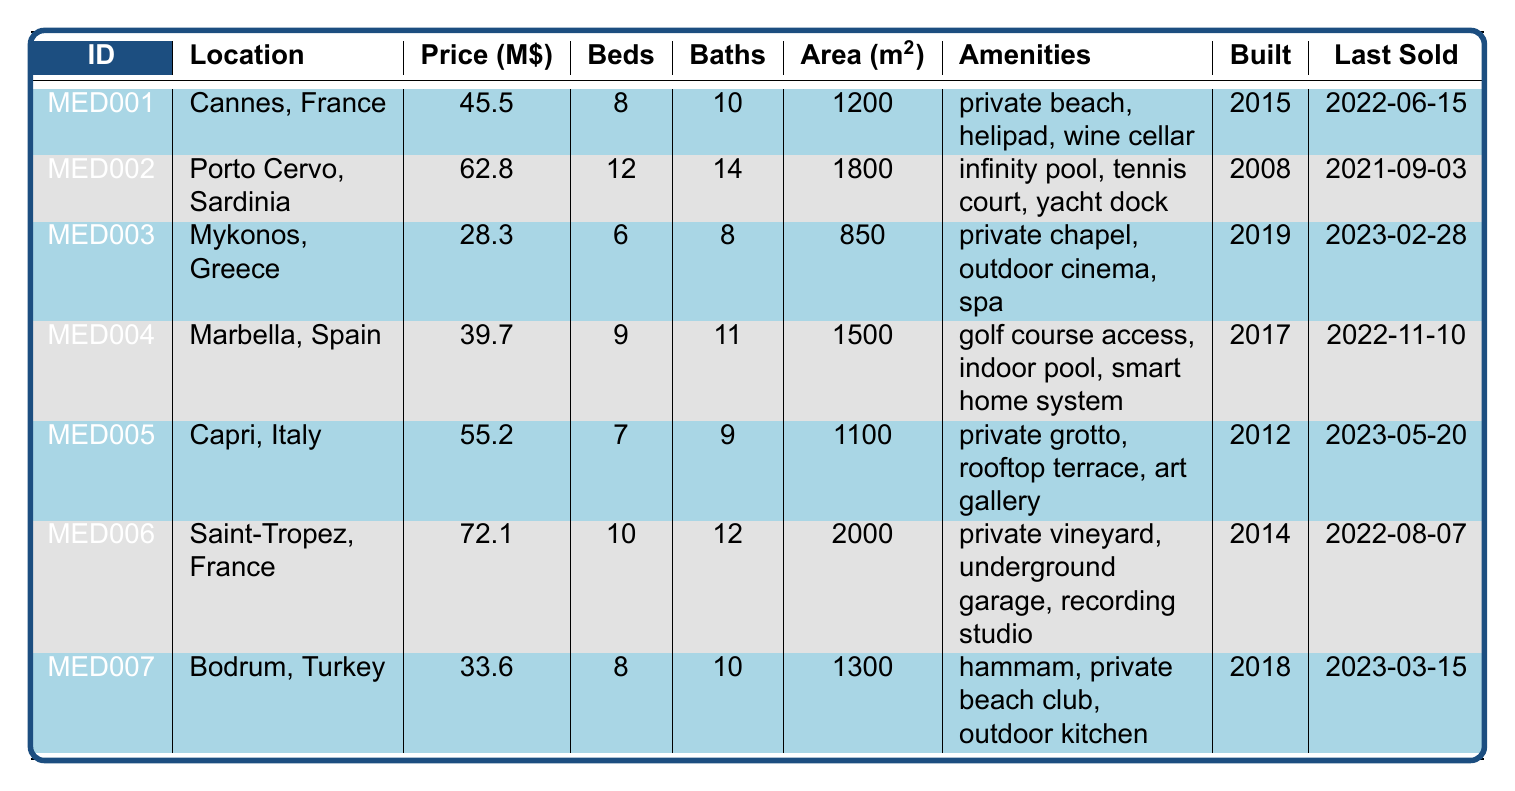What is the most expensive property listed? The price for each property is listed, and the highest is 72.1 million for the property in Saint-Tropez, France.
Answer: Saint-Tropez, France How many bathrooms does the property in Porto Cervo have? The table shows that the Porto Cervo property has 14 bathrooms.
Answer: 14 What is the total number of bedrooms across all properties? Adding up the bedrooms: 8+12+6+9+7+10+8 = 60.
Answer: 60 Which property was last sold the most recently? The last sold dates are compared; the Mykonos property was sold on 2023-02-28, which is the most recent date.
Answer: Mykonos, Greece Is there a property with an infinity pool? Yes, the Porto Cervo property has an infinity pool listed among its amenities.
Answer: Yes What is the average price of all listed properties? The total price is 45.5 + 62.8 + 28.3 + 39.7 + 55.2 + 72.1 + 33.6 = 337.2 million. There are 7 properties, so the average is 337.2 / 7 = 48.17 million.
Answer: 48.17 How many properties were built after 2015? The properties built after 2015 are Mykonos, Marbella, Capri, Bodrum, which totals 4 properties.
Answer: 4 Which property has the largest area? The area of Saint-Tropez is 2000 square meters, which is the largest compared to others listed in the table.
Answer: Saint-Tropez, France Do any properties have a private beach? Yes, both Cannes and Bodrum properties have a private beach as part of their amenities.
Answer: Yes Which property has the fewest bathrooms? Comparing the number of bathrooms, the Mykonos property has the fewest with 8 bathrooms.
Answer: Mykonos, Greece 